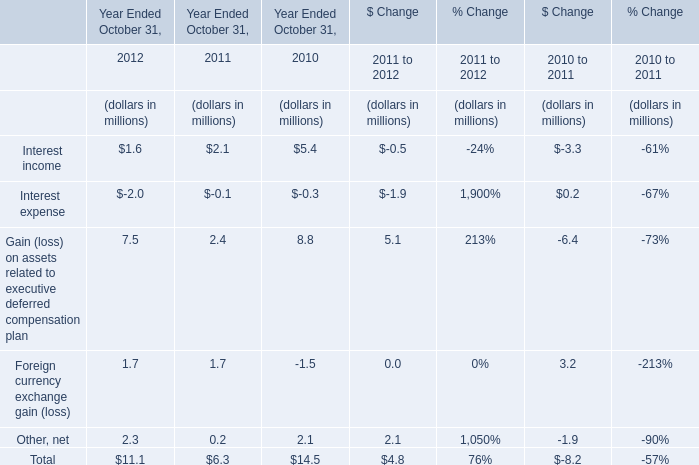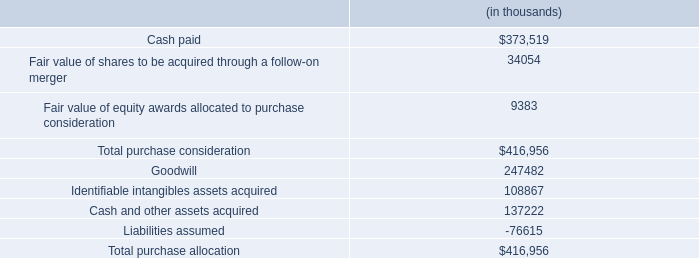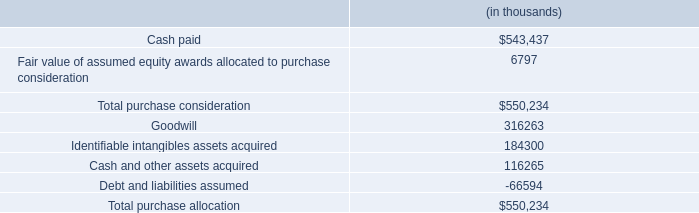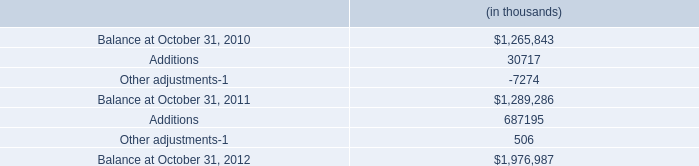what percentage of the total purchase consideration was for intangible assets? 
Computations: ((316263 + 184300) / 550234)
Answer: 0.90973. 